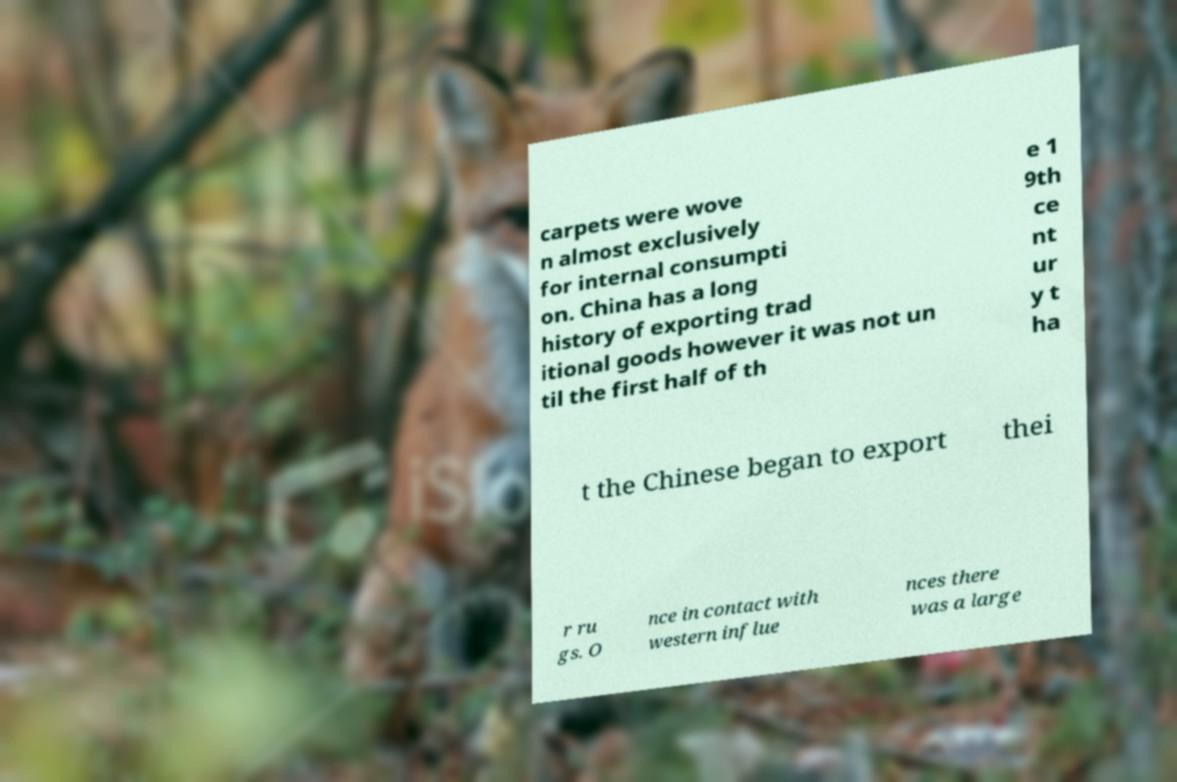Can you read and provide the text displayed in the image?This photo seems to have some interesting text. Can you extract and type it out for me? carpets were wove n almost exclusively for internal consumpti on. China has a long history of exporting trad itional goods however it was not un til the first half of th e 1 9th ce nt ur y t ha t the Chinese began to export thei r ru gs. O nce in contact with western influe nces there was a large 